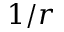<formula> <loc_0><loc_0><loc_500><loc_500>1 / r</formula> 